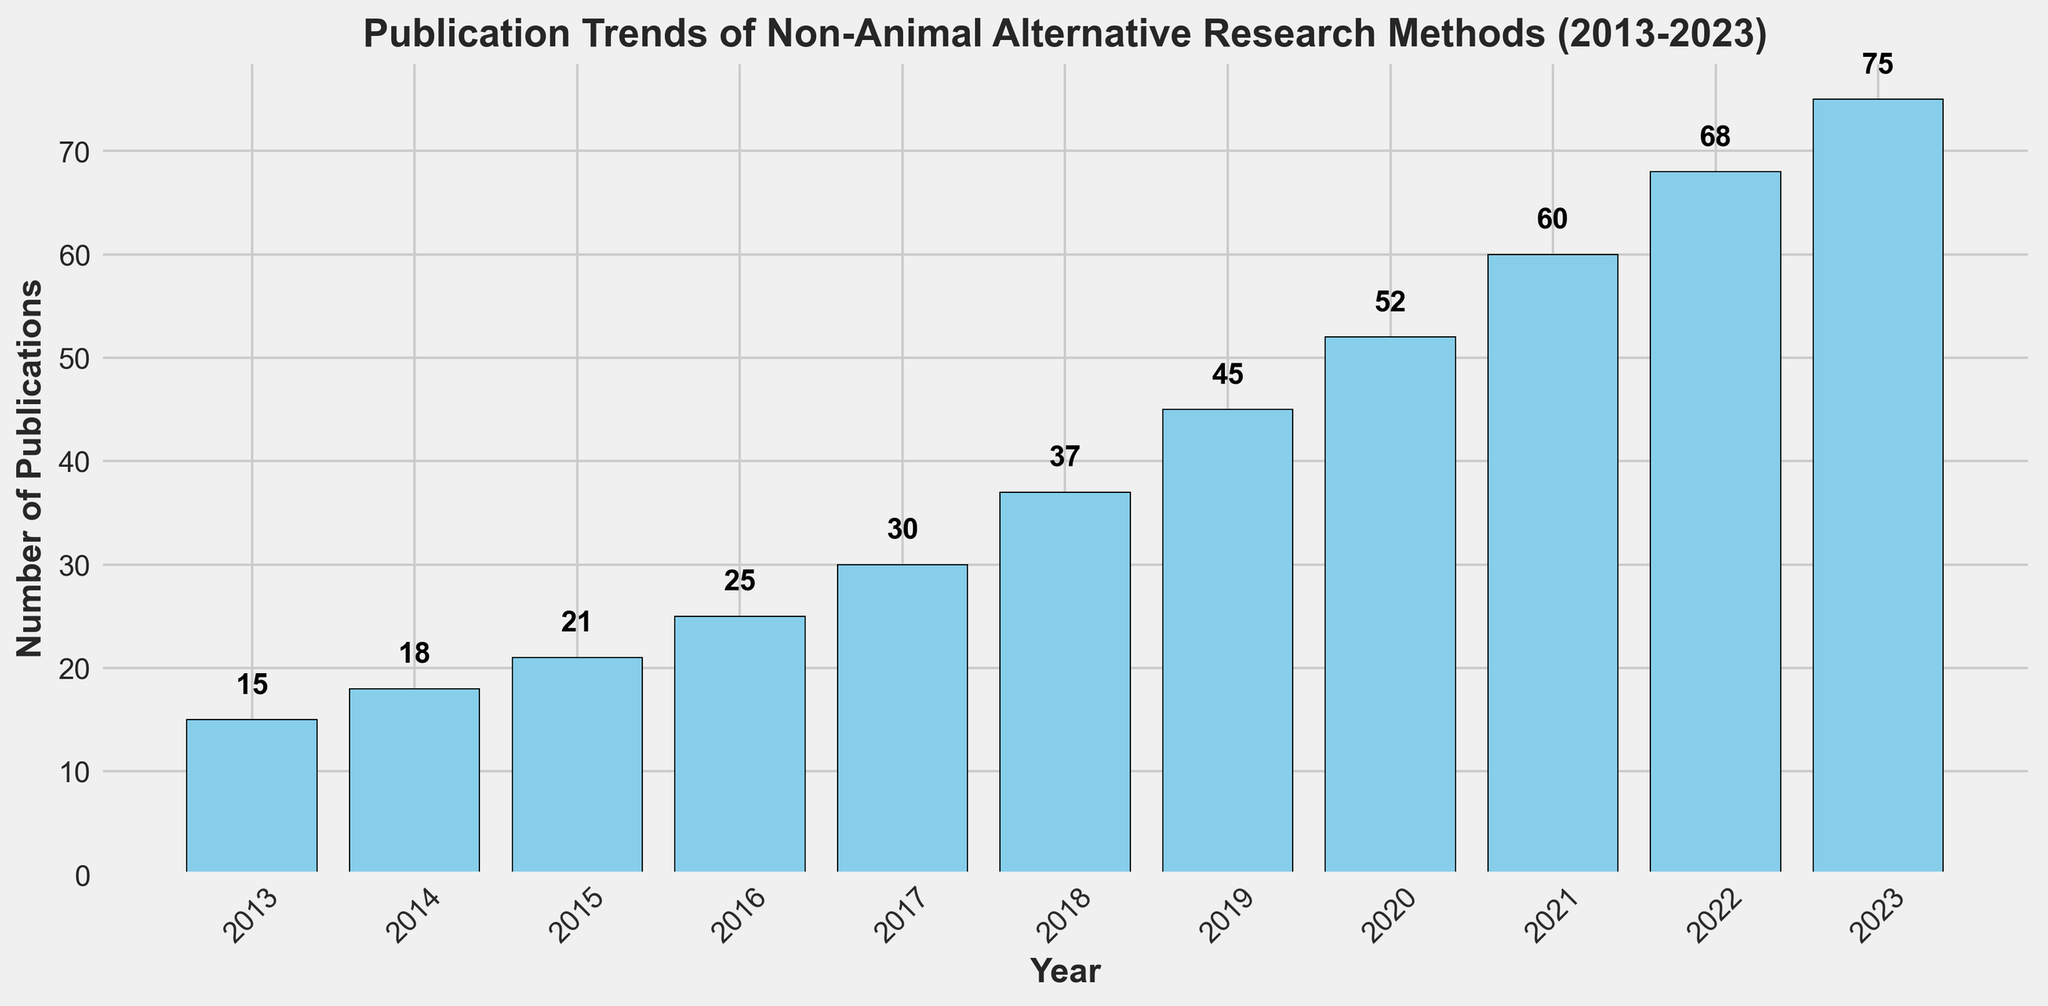What is the overall trend of the number of publications from 2013 to 2023? The figure shows the number of publications increasing each year from 2013 to 2023. This upward trend indicates growing interest or advancements in non-animal alternative research methods over the last decade.
Answer: The number of publications is increasing Which year saw the highest number of publications? By looking at the height of the bars in the histogram, the highest bar corresponds to the year 2023, indicating the highest number of publications in that year.
Answer: 2023 Which two consecutive years show the largest increase in the number of publications? To find this, we need to look for the biggest jump between any two successive bars. Comparing each pair of consecutive years, the largest increase is from 2018 (37 publications) to 2019 (45 publications), an increase of 8 publications.
Answer: 2018 to 2019 What’s the total number of publications over the entire decade? Summing up the number of publications from each year: 15 + 18 + 21 + 25 + 30 + 37 + 45 + 52 + 60 + 68 + 75 = 446.
Answer: 446 In which year did the number of publications first exceed 50? Observing the heights of the bars, the year 2020 is the first to exceed the 50-publication mark with 52 publications.
Answer: 2020 Which years have fewer than 30 publications? By examining each bar’s height, the years with fewer than 30 publications are 2013 (15), 2014 (18), and 2015 (21).
Answer: 2013, 2014, 2015 How many more publications were there in 2023 compared to 2013? Subtracting the number of publications in 2013 (15) from the number in 2023 (75): 75 - 15 = 60.
Answer: 60 What is the average number of publications per year over the decade? Summing up the number of publications from each year and dividing by the number of years (11): (15 + 18 + 21 + 25 + 30 + 37 + 45 + 52 + 60 + 68 + 75) / 11 ≈ 40.55.
Answer: 40.55 Which year saw the smallest increase in the number of publications from the previous year? By calculating the difference in the number of publications year over year and finding the smallest: 
2014-2013 = 3
2015-2014 = 3
2016-2015 = 4
2017-2016 = 5
2018-2017 = 7
2019-2018 = 8
2020-2019 = 7
2021-2020 = 8
2022-2021 = 8
2023-2022 = 7
The smallest increase is between 2013 and 2014 (3 publications).
Answer: 2013 to 2014 